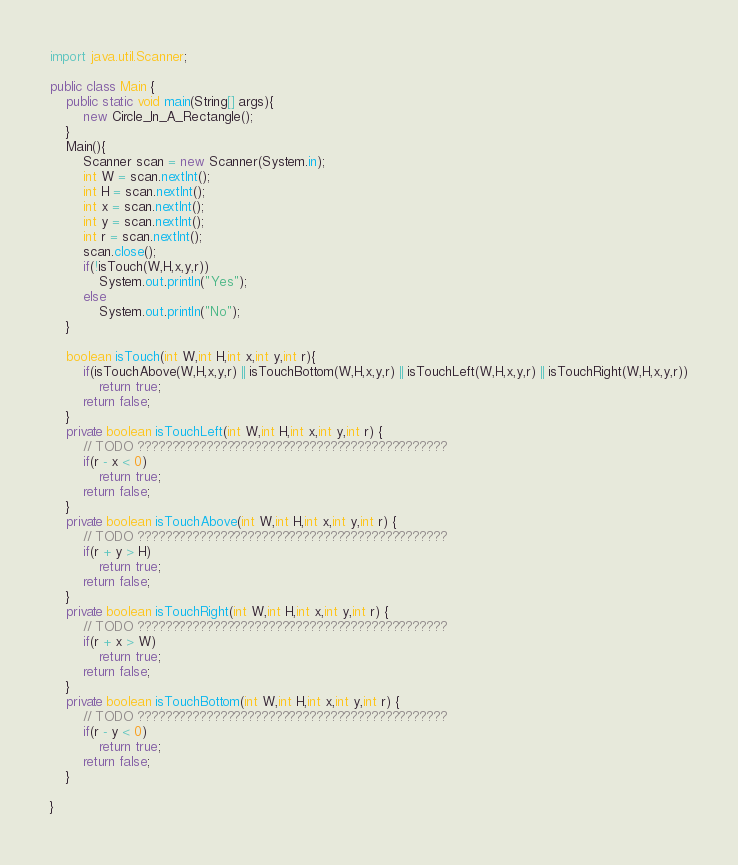Convert code to text. <code><loc_0><loc_0><loc_500><loc_500><_Java_>import java.util.Scanner;

public class Main {
	public static void main(String[] args){
		new Circle_In_A_Rectangle();
	}
	Main(){
		Scanner scan = new Scanner(System.in);
		int W = scan.nextInt();
		int H = scan.nextInt();
		int x = scan.nextInt();
		int y = scan.nextInt();
		int r = scan.nextInt();
		scan.close();
		if(!isTouch(W,H,x,y,r))
			System.out.println("Yes");
		else
			System.out.println("No");
	}

	boolean isTouch(int W,int H,int x,int y,int r){
		if(isTouchAbove(W,H,x,y,r) || isTouchBottom(W,H,x,y,r) || isTouchLeft(W,H,x,y,r) || isTouchRight(W,H,x,y,r))
			return true;
		return false;
	}
	private boolean isTouchLeft(int W,int H,int x,int y,int r) {
		// TODO ?????????????????????????????????????????????
		if(r - x < 0)
			return true;
		return false;
	}
	private boolean isTouchAbove(int W,int H,int x,int y,int r) {
		// TODO ?????????????????????????????????????????????
		if(r + y > H)
			return true;
		return false;
	}
	private boolean isTouchRight(int W,int H,int x,int y,int r) {
		// TODO ?????????????????????????????????????????????
		if(r + x > W)
			return true;
		return false;
	}
	private boolean isTouchBottom(int W,int H,int x,int y,int r) {
		// TODO ?????????????????????????????????????????????
		if(r - y < 0)
			return true;
		return false;
	}

}</code> 